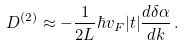<formula> <loc_0><loc_0><loc_500><loc_500>D ^ { ( 2 ) } \approx - \frac { 1 } { 2 L } \hbar { v } _ { F } | t | \frac { d \delta \alpha } { d k } \, .</formula> 